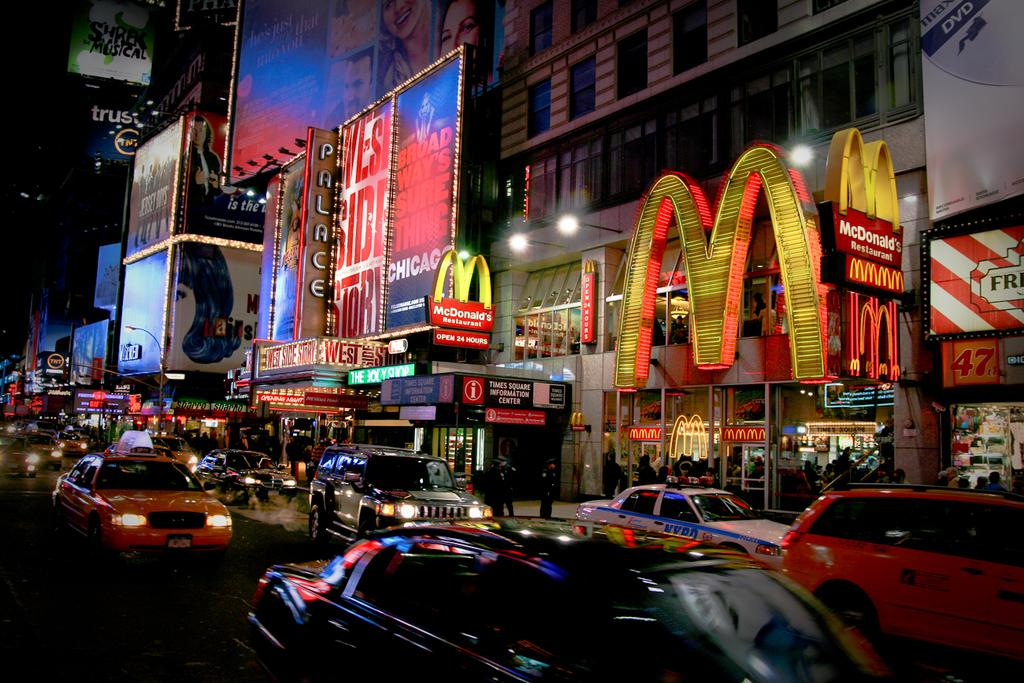<image>
Write a terse but informative summary of the picture. a street that has the letter M next to it 